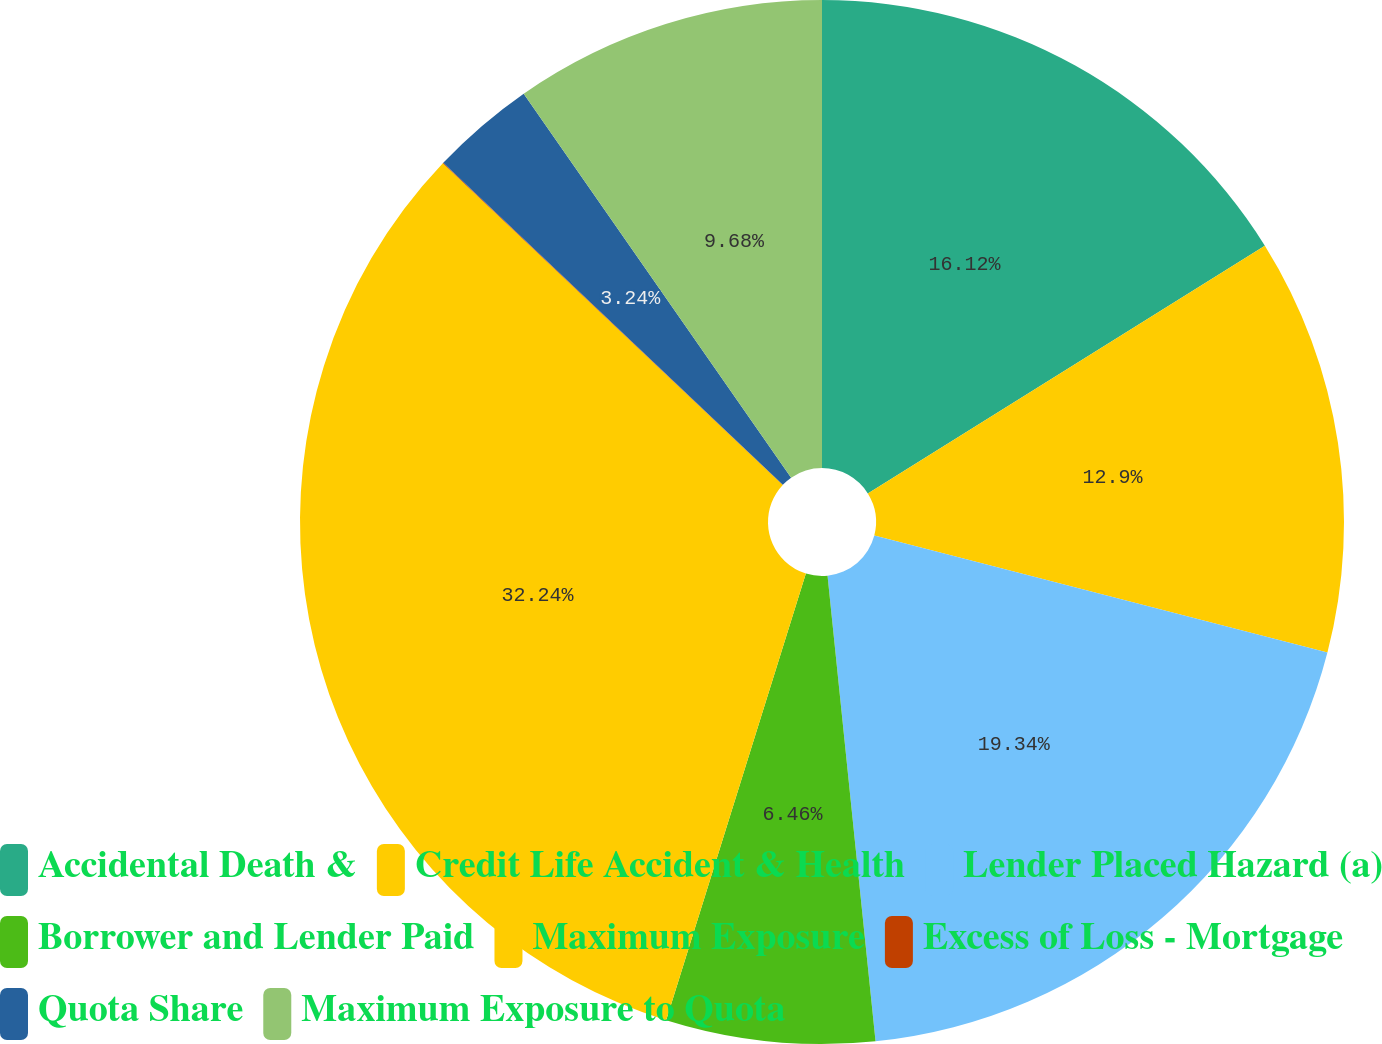Convert chart to OTSL. <chart><loc_0><loc_0><loc_500><loc_500><pie_chart><fcel>Accidental Death &<fcel>Credit Life Accident & Health<fcel>Lender Placed Hazard (a)<fcel>Borrower and Lender Paid<fcel>Maximum Exposure<fcel>Excess of Loss - Mortgage<fcel>Quota Share<fcel>Maximum Exposure to Quota<nl><fcel>16.12%<fcel>12.9%<fcel>19.34%<fcel>6.46%<fcel>32.23%<fcel>0.02%<fcel>3.24%<fcel>9.68%<nl></chart> 